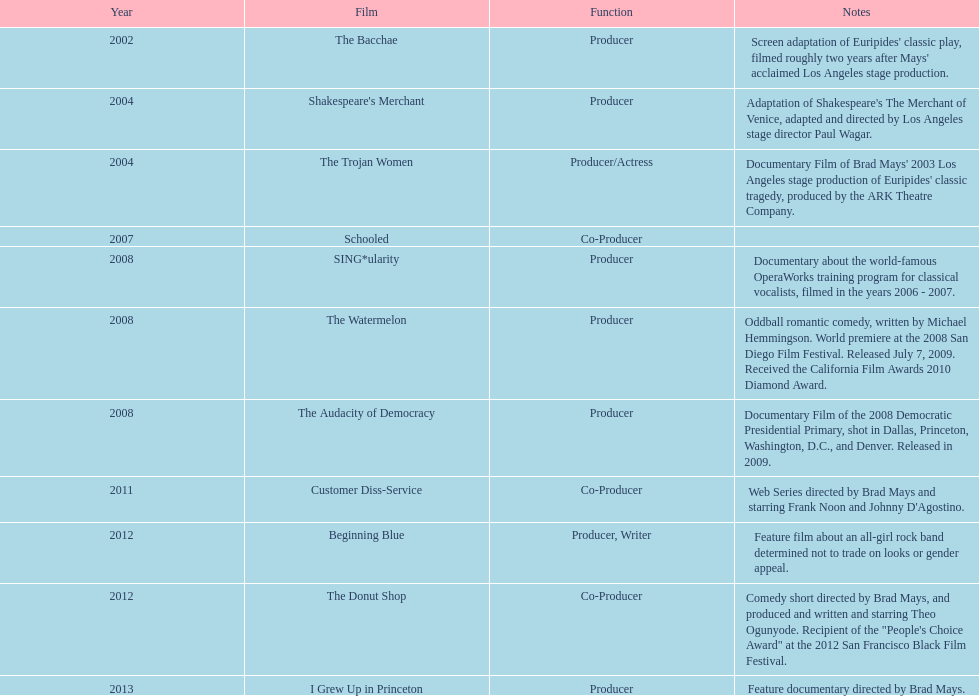How long was the film schooled out before beginning blue? 5 years. 